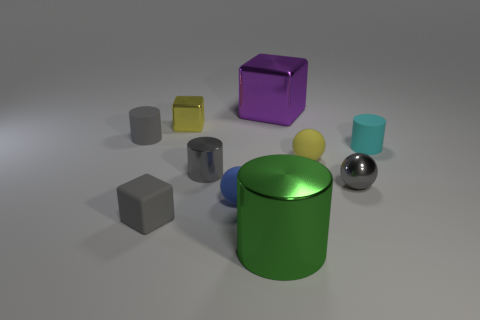Subtract all brown cylinders. Subtract all red cubes. How many cylinders are left? 4 Subtract all blocks. How many objects are left? 7 Add 3 blue rubber spheres. How many blue rubber spheres are left? 4 Add 3 yellow rubber things. How many yellow rubber things exist? 4 Subtract 0 purple cylinders. How many objects are left? 10 Subtract all large purple shiny blocks. Subtract all tiny gray blocks. How many objects are left? 8 